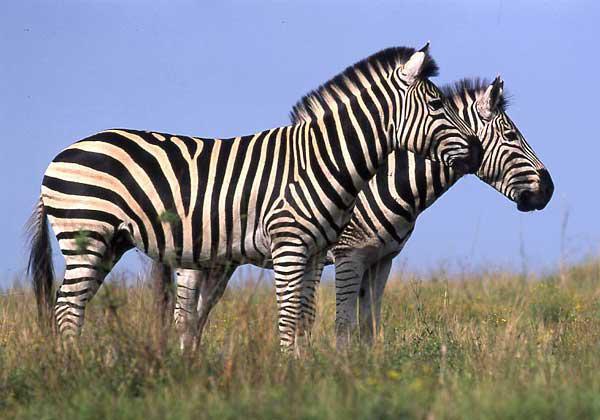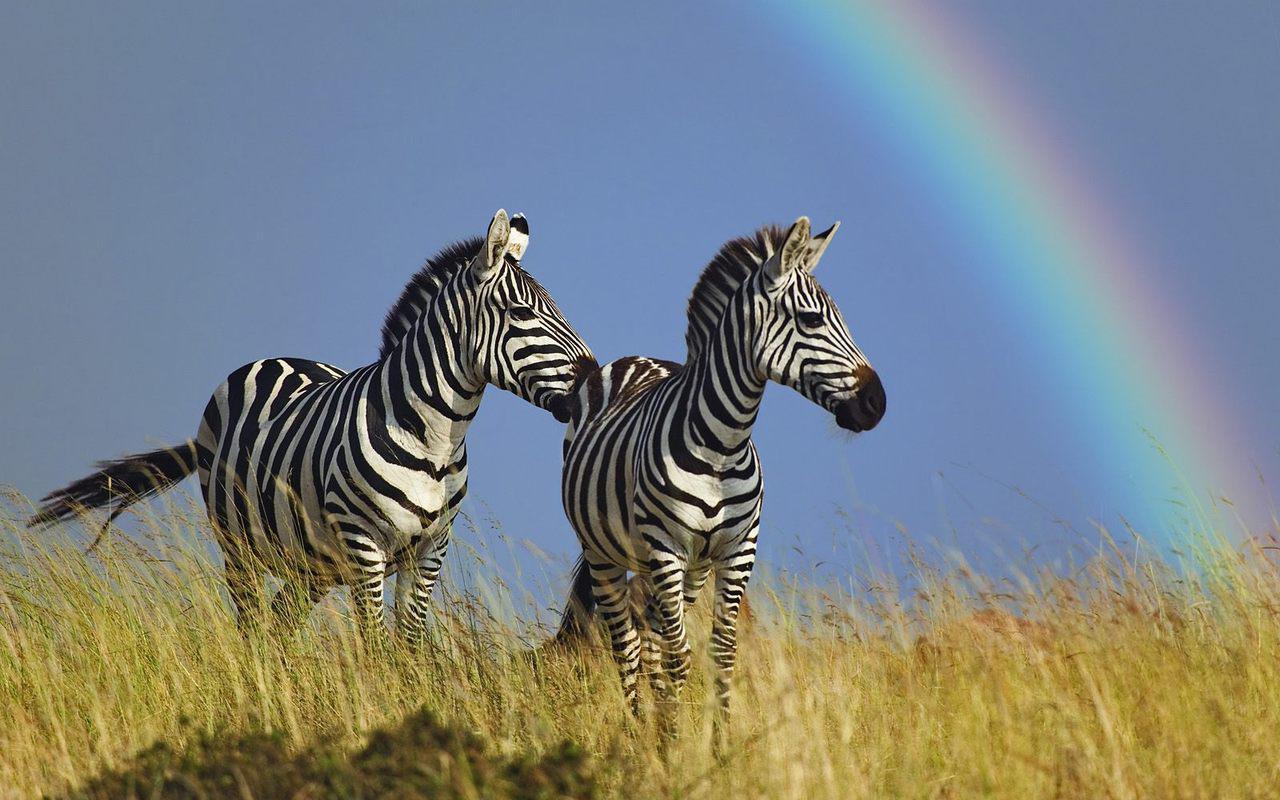The first image is the image on the left, the second image is the image on the right. Evaluate the accuracy of this statement regarding the images: "The left image shows a right-turned zebra standing closest to the camera, with its head resting on the shoulders of a left-turned zebra, and the left-turned zebra with its head resting on the shoulders of the right-turned zebra.". Is it true? Answer yes or no. No. The first image is the image on the left, the second image is the image on the right. Analyze the images presented: Is the assertion "There are two zebras with there noses on the arch of the other zebras back." valid? Answer yes or no. No. 